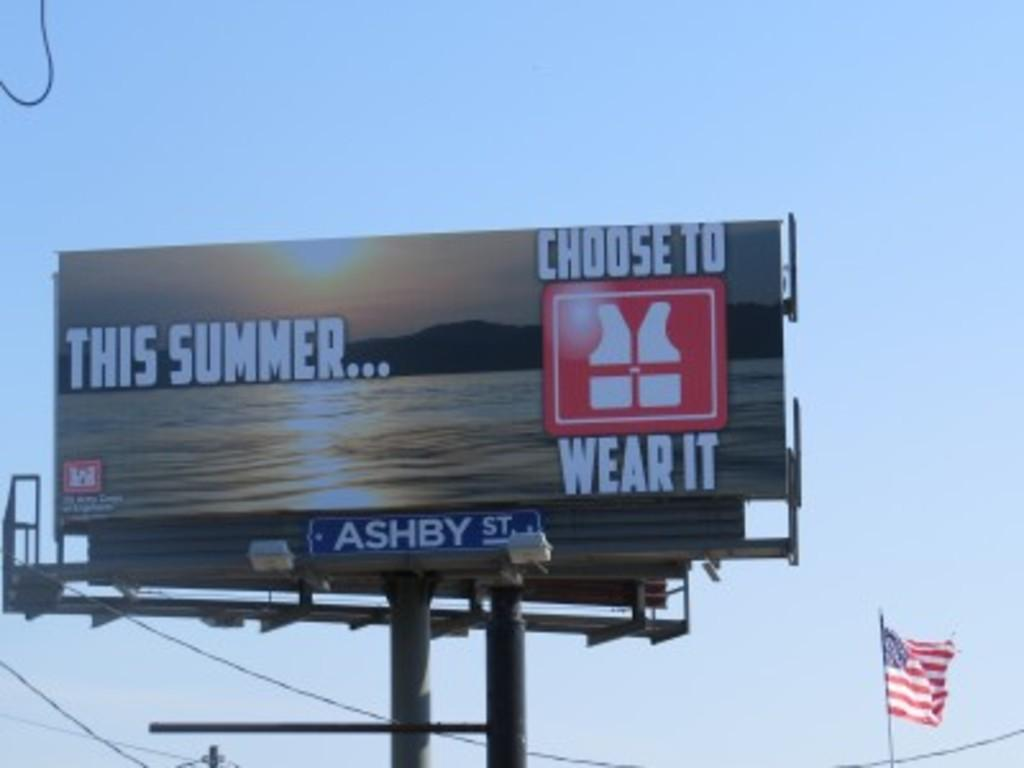<image>
Give a short and clear explanation of the subsequent image. Billboard telling you to choose to wear it this summer 